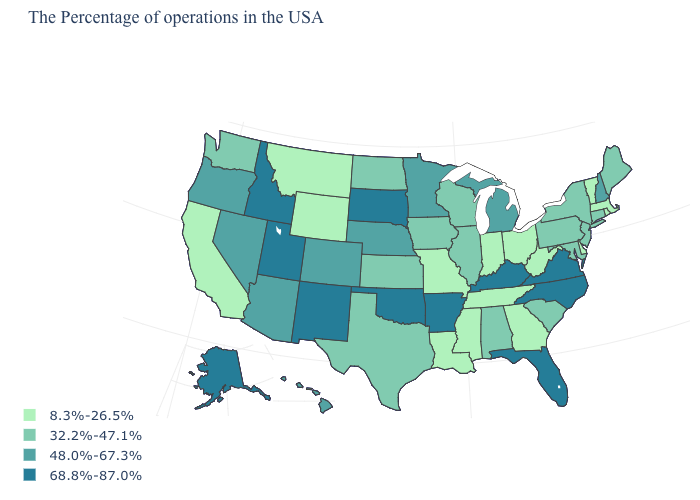What is the value of Kansas?
Answer briefly. 32.2%-47.1%. Which states have the lowest value in the West?
Be succinct. Wyoming, Montana, California. What is the value of Rhode Island?
Quick response, please. 8.3%-26.5%. Does the first symbol in the legend represent the smallest category?
Concise answer only. Yes. Is the legend a continuous bar?
Give a very brief answer. No. What is the value of Minnesota?
Answer briefly. 48.0%-67.3%. Does the first symbol in the legend represent the smallest category?
Quick response, please. Yes. Does the first symbol in the legend represent the smallest category?
Keep it brief. Yes. What is the lowest value in the USA?
Concise answer only. 8.3%-26.5%. Among the states that border New Jersey , which have the lowest value?
Write a very short answer. Delaware. Does Minnesota have the lowest value in the MidWest?
Answer briefly. No. Among the states that border Ohio , which have the lowest value?
Answer briefly. West Virginia, Indiana. Name the states that have a value in the range 48.0%-67.3%?
Concise answer only. New Hampshire, Michigan, Minnesota, Nebraska, Colorado, Arizona, Nevada, Oregon, Hawaii. What is the value of Texas?
Short answer required. 32.2%-47.1%. 